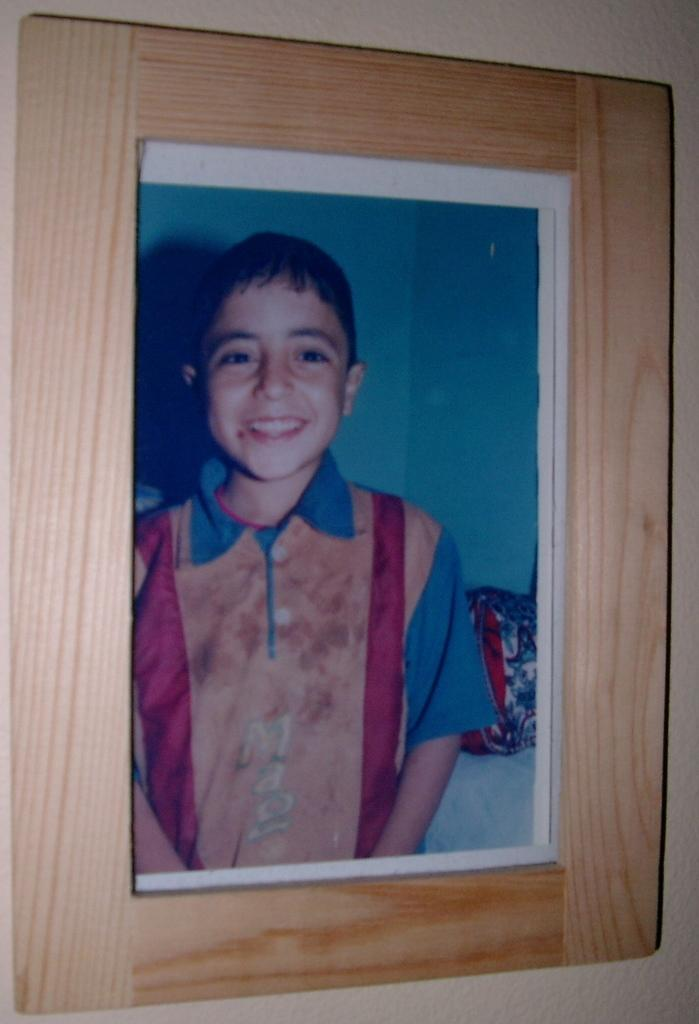What object is present in the image that typically holds a picture? There is a photo frame in the image. What can be seen inside the photo frame? The photo frame contains a picture of a boy. What is the boy in the photo wearing? The boy in the photo is wearing a T-shirt. What else can be seen in the image besides the photo frame? There is a background in the image, and another boy is present in the background. What type of oil is being used by the boy in the background of the image? There is no oil present in the image, nor is there any indication that the boy in the background is using oil for any purpose. 